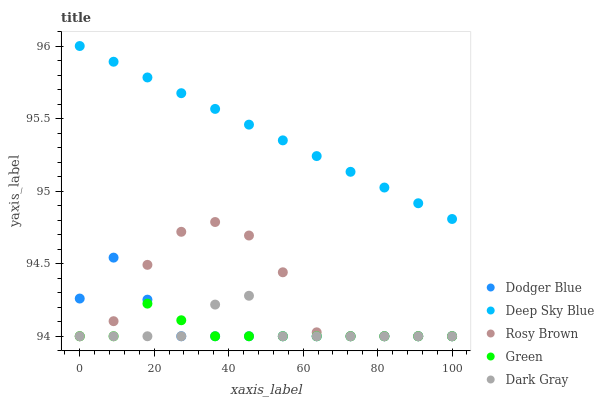Does Green have the minimum area under the curve?
Answer yes or no. Yes. Does Deep Sky Blue have the maximum area under the curve?
Answer yes or no. Yes. Does Rosy Brown have the minimum area under the curve?
Answer yes or no. No. Does Rosy Brown have the maximum area under the curve?
Answer yes or no. No. Is Deep Sky Blue the smoothest?
Answer yes or no. Yes. Is Rosy Brown the roughest?
Answer yes or no. Yes. Is Green the smoothest?
Answer yes or no. No. Is Green the roughest?
Answer yes or no. No. Does Dark Gray have the lowest value?
Answer yes or no. Yes. Does Deep Sky Blue have the lowest value?
Answer yes or no. No. Does Deep Sky Blue have the highest value?
Answer yes or no. Yes. Does Rosy Brown have the highest value?
Answer yes or no. No. Is Dark Gray less than Deep Sky Blue?
Answer yes or no. Yes. Is Deep Sky Blue greater than Green?
Answer yes or no. Yes. Does Dodger Blue intersect Dark Gray?
Answer yes or no. Yes. Is Dodger Blue less than Dark Gray?
Answer yes or no. No. Is Dodger Blue greater than Dark Gray?
Answer yes or no. No. Does Dark Gray intersect Deep Sky Blue?
Answer yes or no. No. 